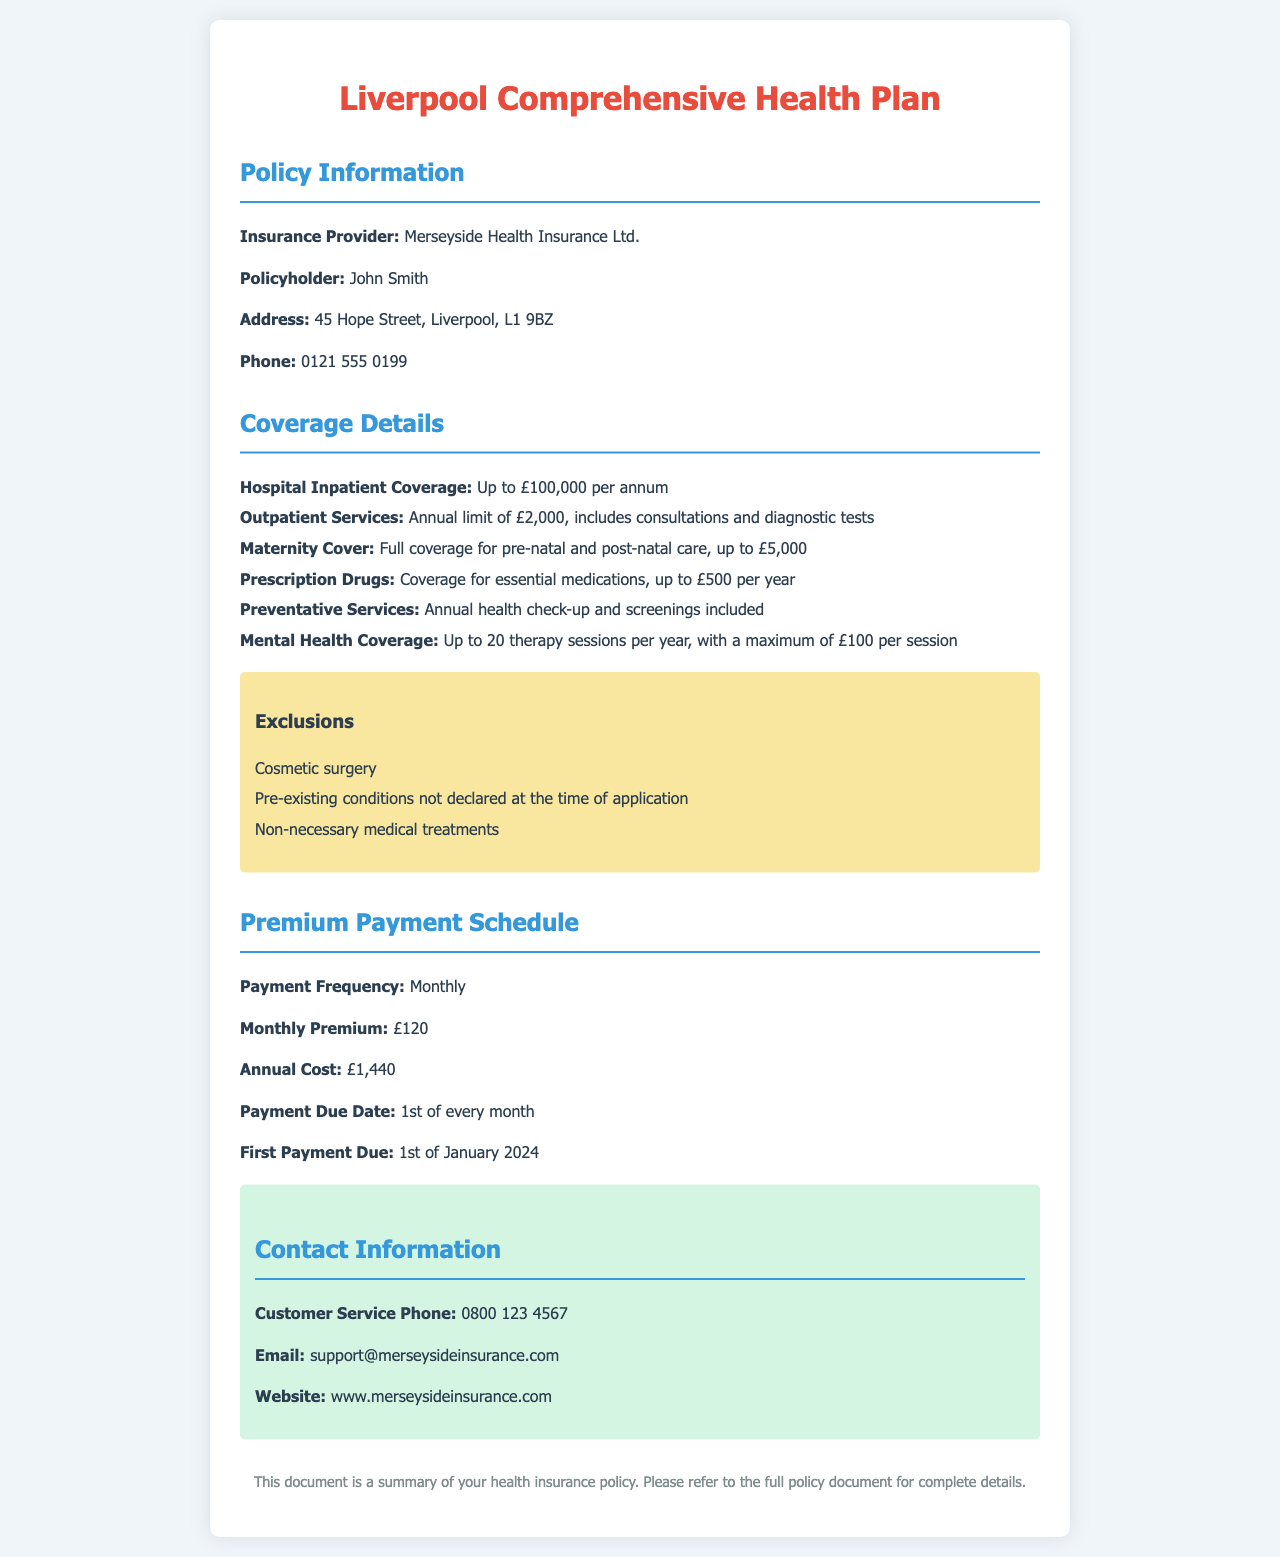What is the insurance provider? The insurance provider is listed as Merseyside Health Insurance Ltd. in the document.
Answer: Merseyside Health Insurance Ltd Who is the policyholder? The document identifies John Smith as the policyholder.
Answer: John Smith What is the coverage limit for hospital inpatient coverage? The document states the coverage limit is up to £100,000 per annum for hospital inpatient care.
Answer: £100,000 per annum How many therapy sessions are covered under mental health coverage? The document specifies that there are up to 20 therapy sessions covered per year.
Answer: 20 What is the monthly premium amount? The document lists the monthly premium as £120.
Answer: £120 What is the first payment due date? The document indicates that the first payment is due on the 1st of January 2024.
Answer: 1st of January 2024 What is the exclusion related to cosmetic treatments? The document states that cosmetic surgery is an exclusion under the policy.
Answer: Cosmetic surgery What is the total annual cost of the policy? The document calculates the total annual cost as £1,440, based on the monthly premium.
Answer: £1,440 What is included in the preventative services? The document includes annual health check-up and screenings as part of preventative services.
Answer: Annual health check-up and screenings 